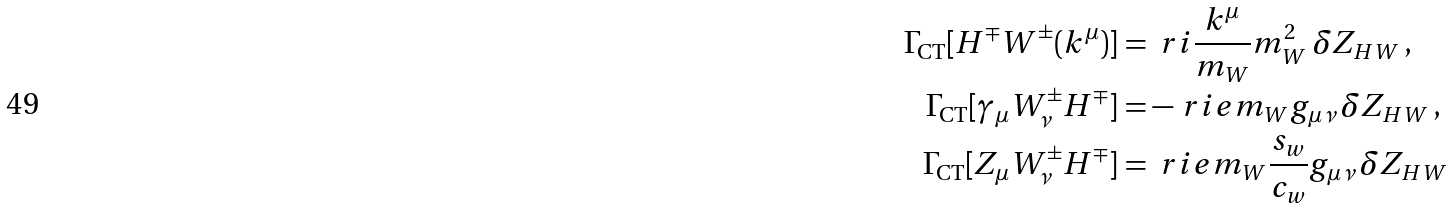Convert formula to latex. <formula><loc_0><loc_0><loc_500><loc_500>\Gamma _ { \text {CT} } [ H ^ { \mp } W ^ { \pm } ( k ^ { \mu } ) ] & = \ r i \frac { k ^ { \mu } } { m _ { W } } m _ { W } ^ { 2 } \, \delta Z _ { H W } \, , \\ \Gamma _ { \text {CT} } [ \gamma _ { \mu } W ^ { \pm } _ { \nu } H ^ { \mp } ] & = - \ r i e m _ { W } g _ { \mu \nu } \, \delta Z _ { H W } \, , \\ \Gamma _ { \text {CT} } [ Z _ { \mu } W ^ { \pm } _ { \nu } H ^ { \mp } ] & = \ r i e m _ { W } \frac { s _ { w } } { c _ { w } } g _ { \mu \nu } \, \delta Z _ { H W }</formula> 